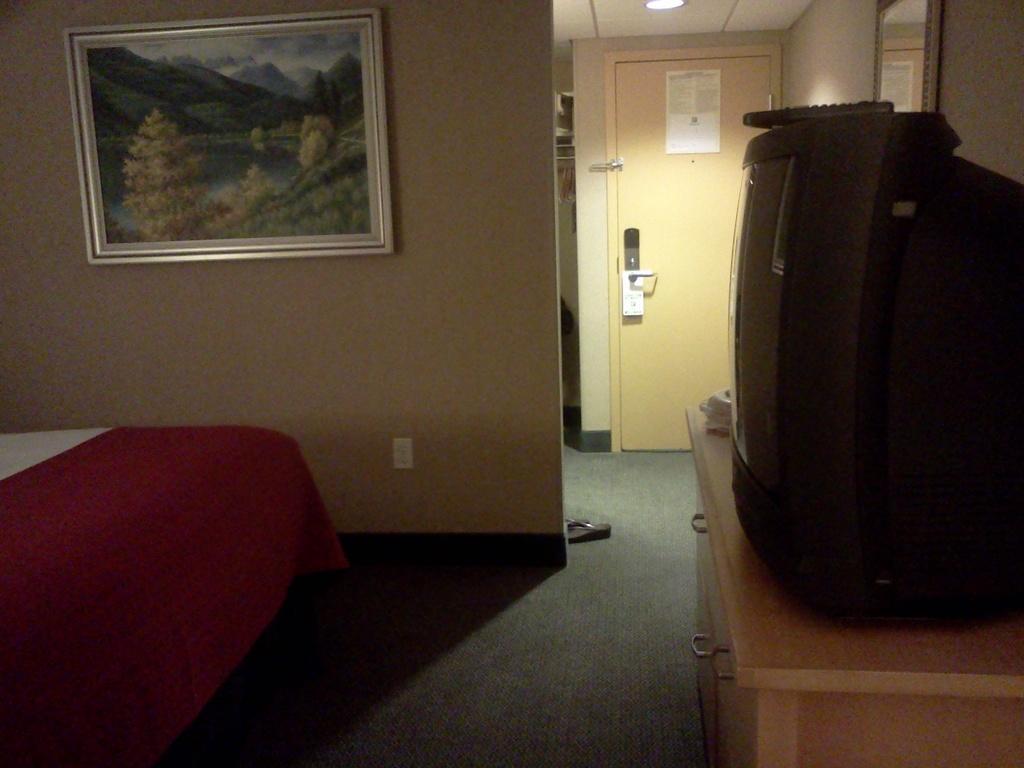Could you give a brief overview of what you see in this image? This image is taken indoors. At the bottom of the image there is a floor. On the left side of the image there is a bed with a bed sheet. On the right side of the image there is a television and remotes on the table. In the background there are a few walls with a picture frame and a door. 